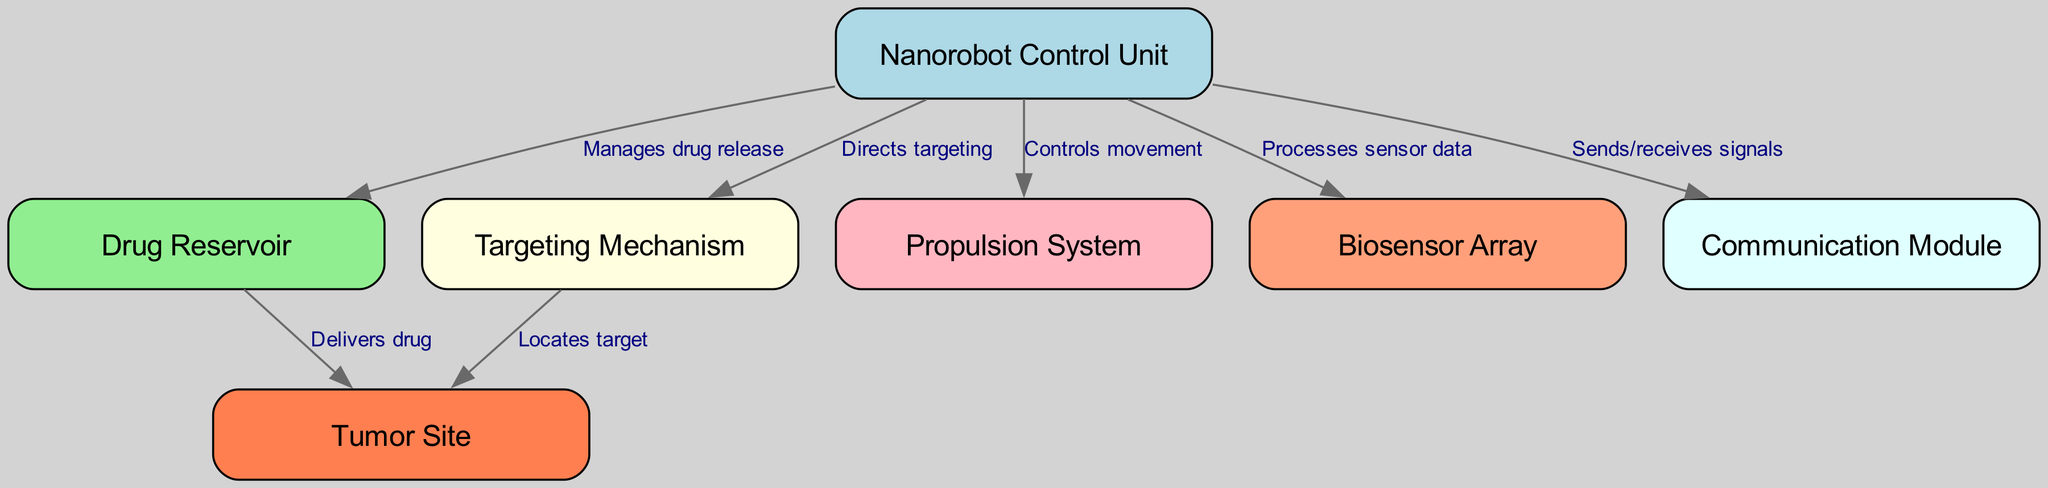What is the total number of nodes in the diagram? The diagram lists seven distinct components related to the nanorobot's design; these are the Nanorobot Control Unit, Drug Reservoir, Targeting Mechanism, Propulsion System, Biosensor Array, Communication Module, and Tumor Site. Counting them yields a total of seven nodes.
Answer: 7 Which node manages drug release? The Drug Reservoir is directly connected to the Nanorobot Control Unit, which indicates that it manages the release of the drug stored within it. Thus, the Drug Reservoir is responsible for drug release management.
Answer: Drug Reservoir What is the relationship between the Targeting Mechanism and the Tumor Site? The Targeting Mechanism directly locates the Tumor Site, as evidenced by the directed edge labeled "Locates target." This indicates that the Targeting Mechanism is responsible for identifying where to deliver the drug.
Answer: Locates target Which component processes sensor data? The Biosensor Array is connected to the Nanorobot Control Unit and is responsible for processing sensor data according to the directed edge labeled "Processes sensor data." This implies that the information gathered by the biosensors is processed by this component.
Answer: Biosensor Array How many edges are present in the diagram? The diagram shows connections between various components (nodes) through directed edges. There are a total of six directed edges, showcasing the interactions among the different components of the nanorobot design.
Answer: 6 What function does the Communication Module serve in the nanorobot system? The Communication Module is involved in sending and receiving signals as indicated by the edge labeled "Sends/receives signals," which links it to the Nanorobot Control Unit. This suggests that the module facilitates communication between the nanorobot and external entities for operational effectiveness.
Answer: Sends/receives signals What directs the movement of the nanorobot? The Propulsion System is specified in the diagram as the component that controls the movement of the nanorobot, shown by the edge labeled "Controls movement" connected to the Nanorobot Control Unit. This defines the role of the Propulsion System in navigation.
Answer: Controls movement Which component delivers the drug to the tumor site? The directed edge labeled "Delivers drug" between the Drug Reservoir and the Tumor Site indicates that the Drug Reservoir is responsible for the actual delivery of the drug to the targeted area. This connection clarifies the functional pathway for drug delivery.
Answer: Delivers drug 